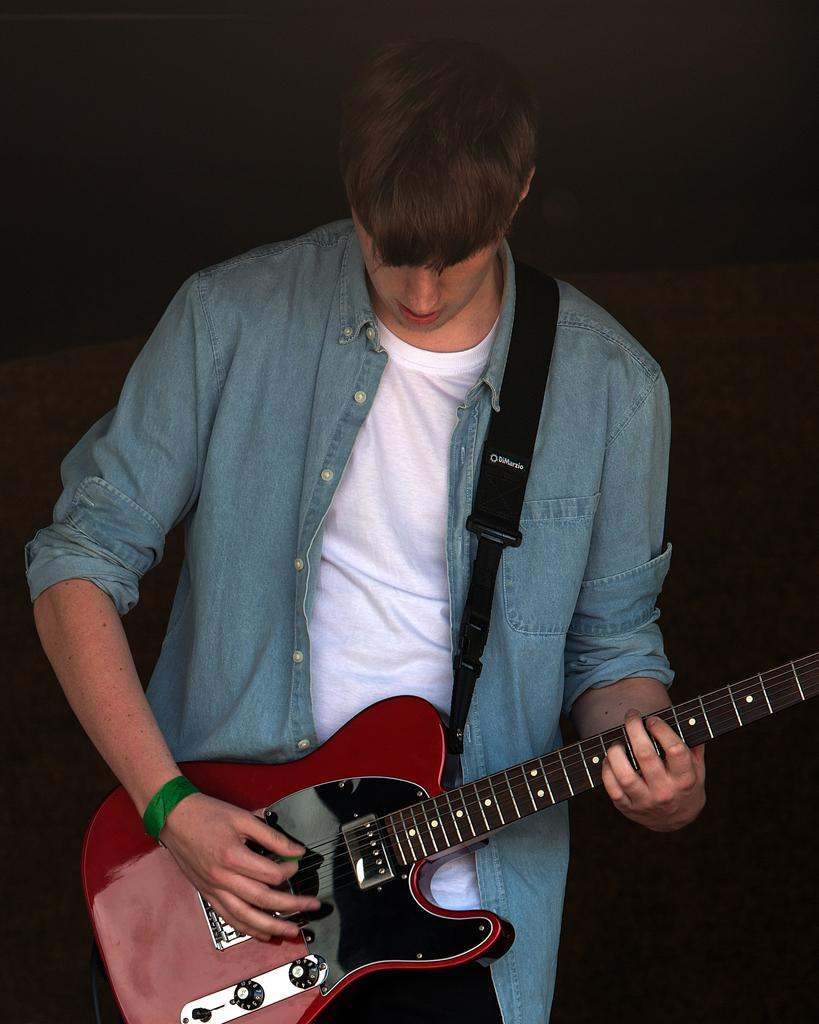What is the main subject of the image? The main subject of the image is a man. What is the man wearing in the image? The man is wearing a jacket in the image. What activity is the man engaged in? The man is playing a guitar in the image. What type of soup is the man eating in the image? There is no soup present in the image; the man is playing a guitar. How many trees can be seen in the image? There are no trees visible in the image; it features a man playing a guitar. 